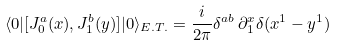<formula> <loc_0><loc_0><loc_500><loc_500>\langle 0 | [ J ^ { a } _ { 0 } ( x ) , J ^ { b } _ { 1 } ( y ) ] | 0 \rangle _ { E . T . } = \frac { i } { 2 \pi } \delta ^ { a b } \, \partial ^ { x } _ { 1 } \delta ( x ^ { 1 } - y ^ { 1 } )</formula> 